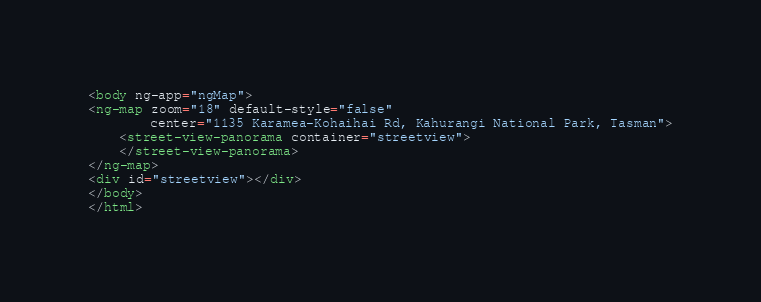Convert code to text. <code><loc_0><loc_0><loc_500><loc_500><_HTML_><body ng-app="ngMap">
<ng-map zoom="18" default-style="false"
        center="1135 Karamea-Kohaihai Rd, Kahurangi National Park, Tasman">
    <street-view-panorama container="streetview">
    </street-view-panorama>
</ng-map>
<div id="streetview"></div>
</body>
</html>
</code> 